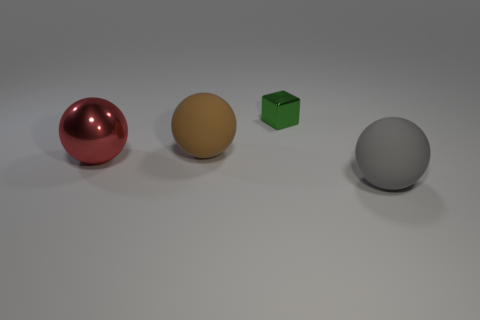Is there a green metal thing?
Your response must be concise. Yes. Is the big red ball that is in front of the brown thing made of the same material as the small green block?
Your answer should be very brief. Yes. How many other cubes have the same size as the green cube?
Provide a succinct answer. 0. Are there the same number of big gray balls that are to the left of the brown rubber ball and big gray matte balls?
Offer a terse response. No. What number of metallic objects are both on the left side of the small green thing and to the right of the big shiny ball?
Keep it short and to the point. 0. The brown sphere that is made of the same material as the gray object is what size?
Provide a short and direct response. Large. What number of other shiny things are the same shape as the brown object?
Provide a succinct answer. 1. Is the number of rubber balls that are to the right of the large gray matte sphere greater than the number of blue cylinders?
Your answer should be very brief. No. There is a large thing that is in front of the large brown ball and to the left of the small green block; what shape is it?
Provide a short and direct response. Sphere. Does the gray thing have the same size as the red metal thing?
Keep it short and to the point. Yes. 